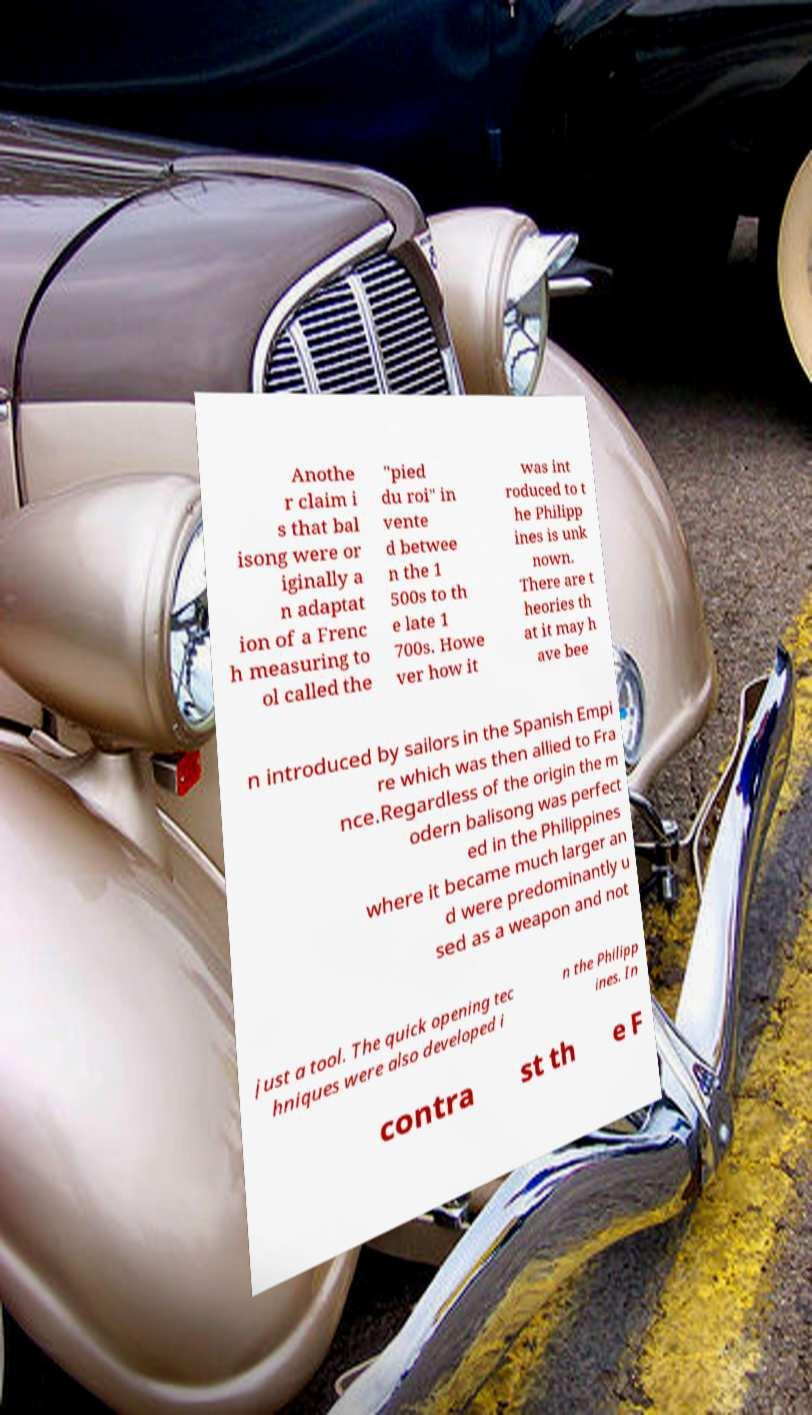There's text embedded in this image that I need extracted. Can you transcribe it verbatim? Anothe r claim i s that bal isong were or iginally a n adaptat ion of a Frenc h measuring to ol called the "pied du roi" in vente d betwee n the 1 500s to th e late 1 700s. Howe ver how it was int roduced to t he Philipp ines is unk nown. There are t heories th at it may h ave bee n introduced by sailors in the Spanish Empi re which was then allied to Fra nce.Regardless of the origin the m odern balisong was perfect ed in the Philippines where it became much larger an d were predominantly u sed as a weapon and not just a tool. The quick opening tec hniques were also developed i n the Philipp ines. In contra st th e F 